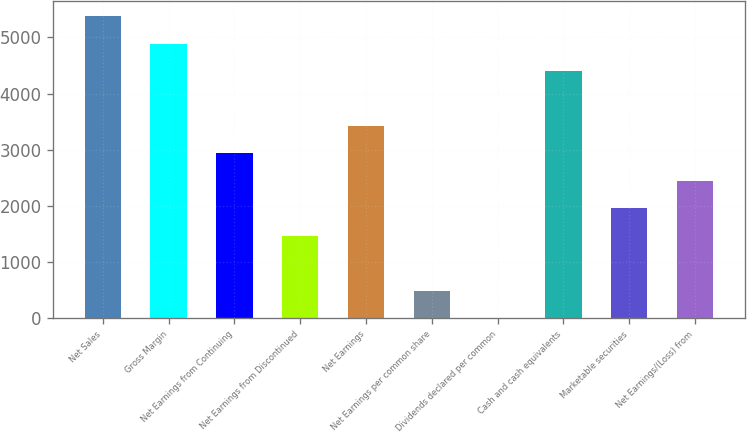Convert chart. <chart><loc_0><loc_0><loc_500><loc_500><bar_chart><fcel>Net Sales<fcel>Gross Margin<fcel>Net Earnings from Continuing<fcel>Net Earnings from Discontinued<fcel>Net Earnings<fcel>Net Earnings per common share<fcel>Dividends declared per common<fcel>Cash and cash equivalents<fcel>Marketable securities<fcel>Net Earnings/(Loss) from<nl><fcel>5380.08<fcel>4891.01<fcel>2934.73<fcel>1467.52<fcel>3423.8<fcel>489.38<fcel>0.31<fcel>4401.94<fcel>1956.59<fcel>2445.66<nl></chart> 